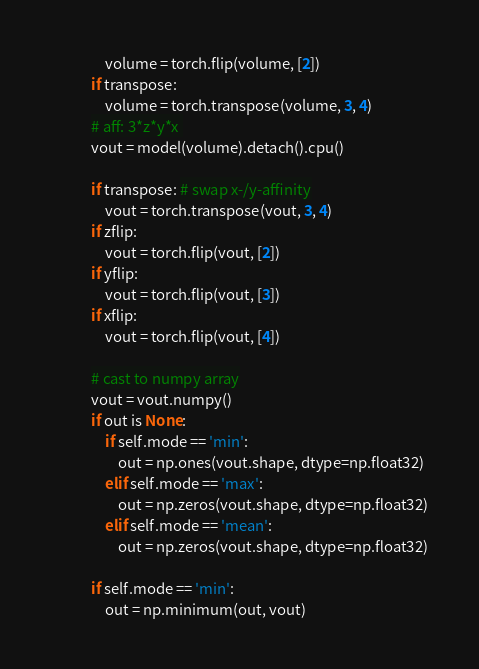<code> <loc_0><loc_0><loc_500><loc_500><_Python_>                volume = torch.flip(volume, [2])
            if transpose:
                volume = torch.transpose(volume, 3, 4)
            # aff: 3*z*y*x 
            vout = model(volume).detach().cpu()

            if transpose: # swap x-/y-affinity
                vout = torch.transpose(vout, 3, 4)
            if zflip:
                vout = torch.flip(vout, [2])
            if yflip:
                vout = torch.flip(vout, [3])
            if xflip:
                vout = torch.flip(vout, [4])
                
            # cast to numpy array
            vout = vout.numpy()
            if out is None:
                if self.mode == 'min':
                    out = np.ones(vout.shape, dtype=np.float32)
                elif self.mode == 'max':
                    out = np.zeros(vout.shape, dtype=np.float32)
                elif self.mode == 'mean':
                    out = np.zeros(vout.shape, dtype=np.float32)

            if self.mode == 'min':
                out = np.minimum(out, vout)</code> 